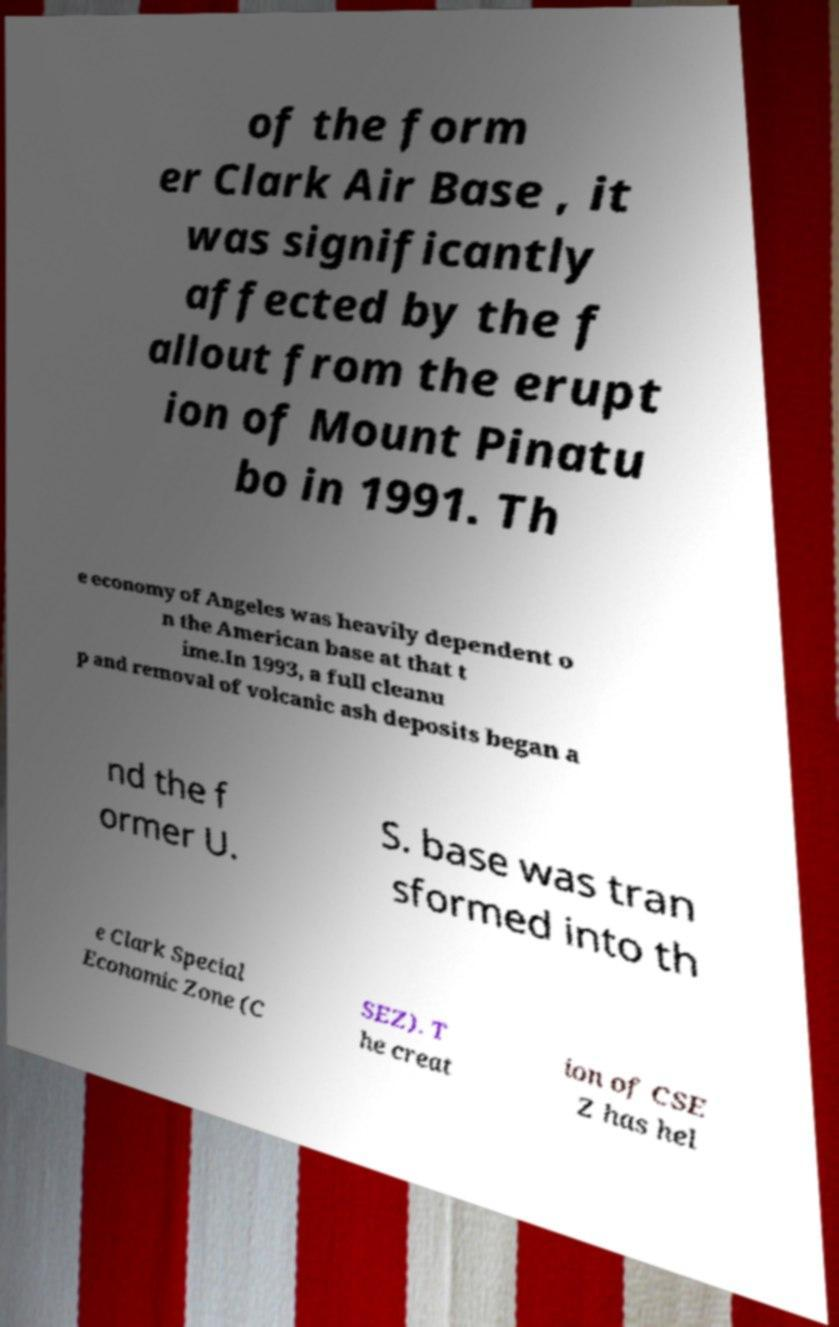Could you assist in decoding the text presented in this image and type it out clearly? of the form er Clark Air Base , it was significantly affected by the f allout from the erupt ion of Mount Pinatu bo in 1991. Th e economy of Angeles was heavily dependent o n the American base at that t ime.In 1993, a full cleanu p and removal of volcanic ash deposits began a nd the f ormer U. S. base was tran sformed into th e Clark Special Economic Zone (C SEZ). T he creat ion of CSE Z has hel 